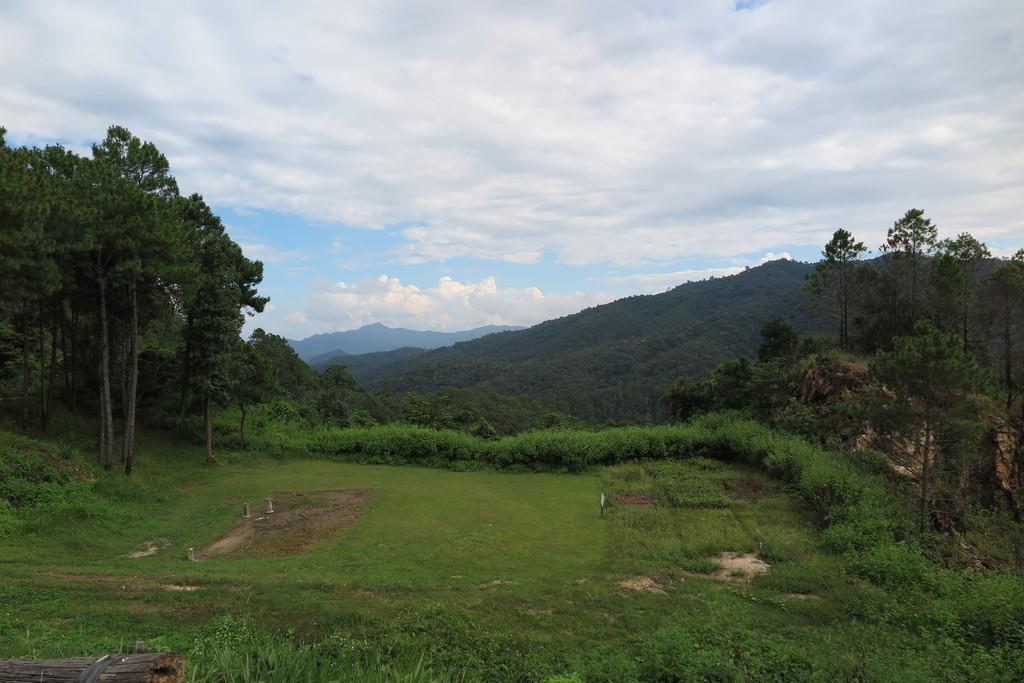What type of natural elements are present in the image? There are trees and plants in the image. What is the color of the trees and plants? The trees and plants are green in color. What can be seen in the background of the image? There are mountains in the background of the image. What is visible in the sky in the image? The sky has a white and blue color. Can you see any marbles rolling down the slope in the image? There are no marbles or slopes present in the image; it features trees, plants, mountains, and a sky with a white and blue color. 